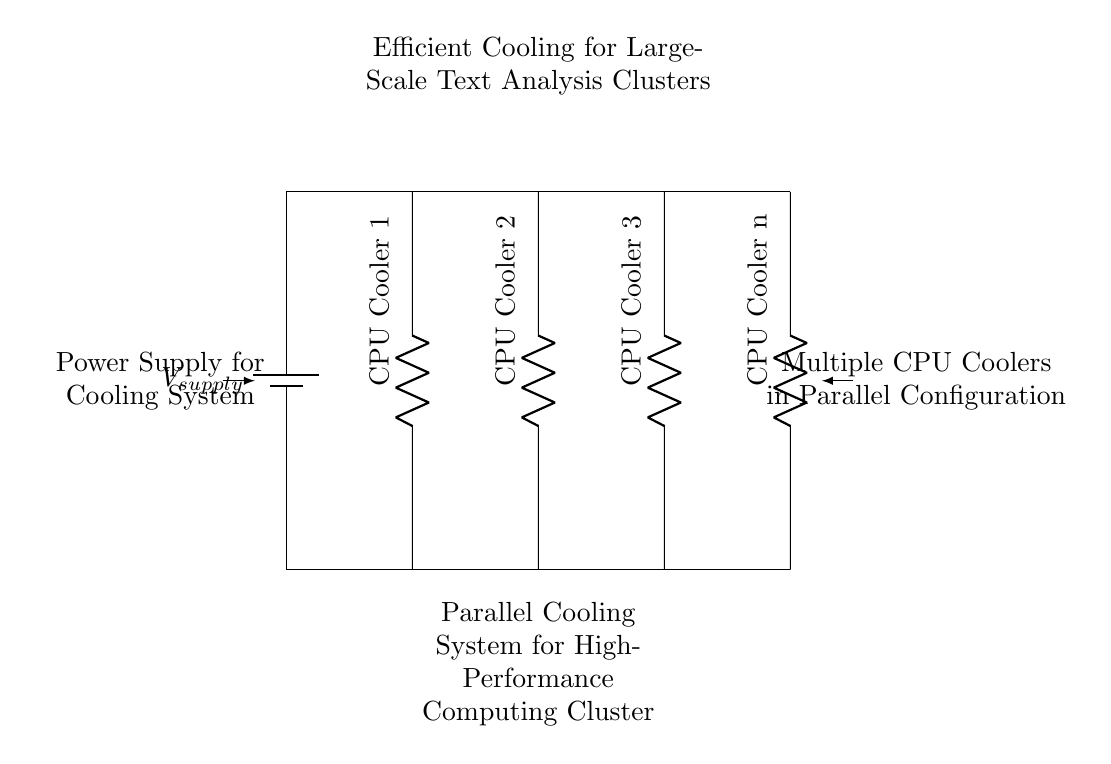What is the type of circuit configuration shown? The circuit configuration is a parallel circuit, which can be identified by the multiple branches where each CPU cooler is connected separately to the voltage supply, allowing each to operate independently.
Answer: Parallel How many CPU coolers are present in this circuit? The diagram shows 'n' CPU coolers, represented as a generic term indicating multiple coolers connected in parallel. Since there is no specific number, 'n' refers to an unspecified quantity.
Answer: n What is the purpose of the power supply in this circuit? The power supply provides the necessary voltage to the entire parallel setup, ensuring that all CPU coolers receive the same voltage value to function effectively for cooling.
Answer: Power supply What effect does the parallel configuration have on current through each CPU cooler? In a parallel configuration, the total current is divided among the branches, meaning each CPU cooler receives an equal share of the total current based on its resistance, allowing for consistent cooling without the risk of overload on one branch.
Answer: Divided current What is the primary function of this circuit setup? This circuit setup is designed for efficient cooling, particularly crucial for high-performance computing clusters, which generate significant heat during intensive tasks such as large-scale text analysis.
Answer: Efficient cooling How does adding more CPU coolers affect the overall cooling efficiency? Adding more CPU coolers in parallel increases the overall cooling capacity and redundancy of the system, ensuring that if one cooler fails, the others can still maintain acceptable temperatures.
Answer: Increases efficiency 